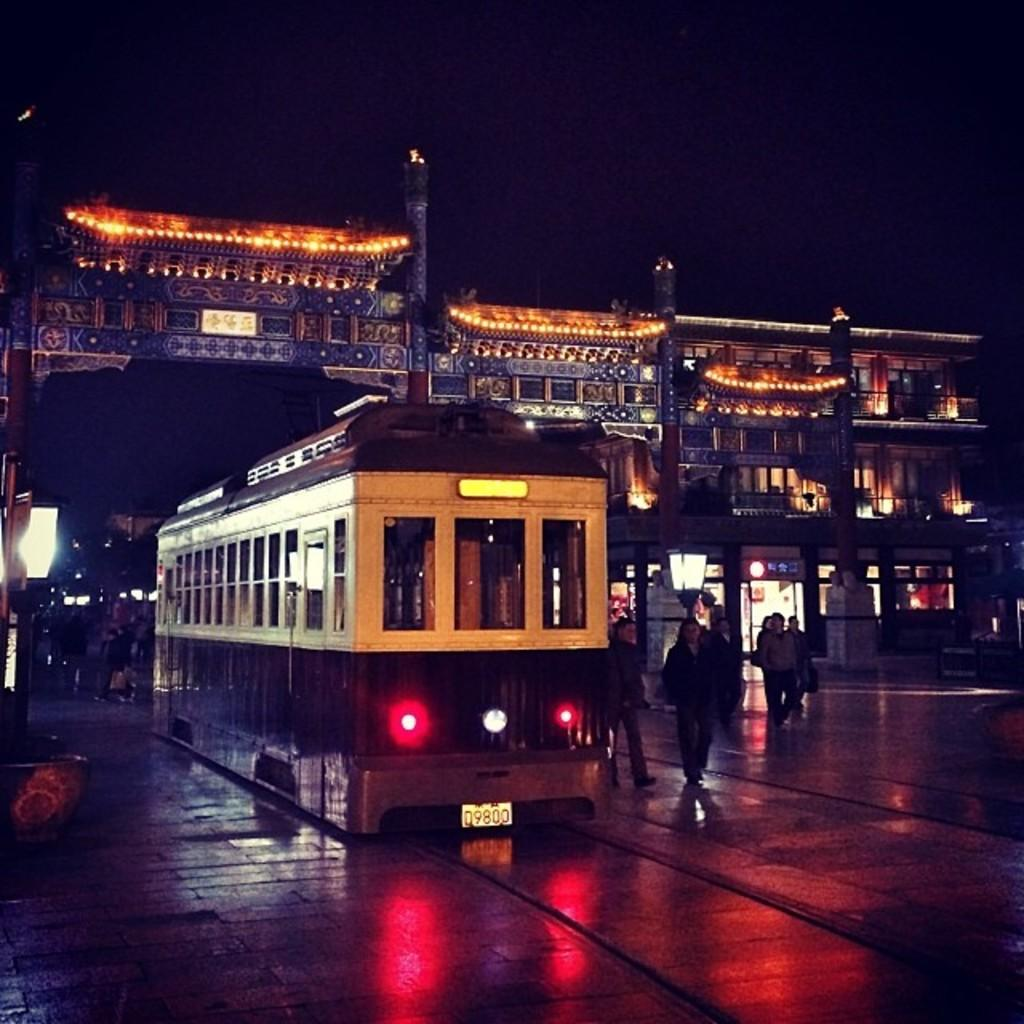What is the main subject in the center of the image? There is a bus in the center of the image. What are the people near the bus doing? People are walking on the road beside the bus. What can be seen in the background of the image? There are buildings and the sky visible in the background of the image. What type of sense can be seen in the image? There is no sense present in the image; it is a visual representation of a bus, people, and the surrounding environment. 